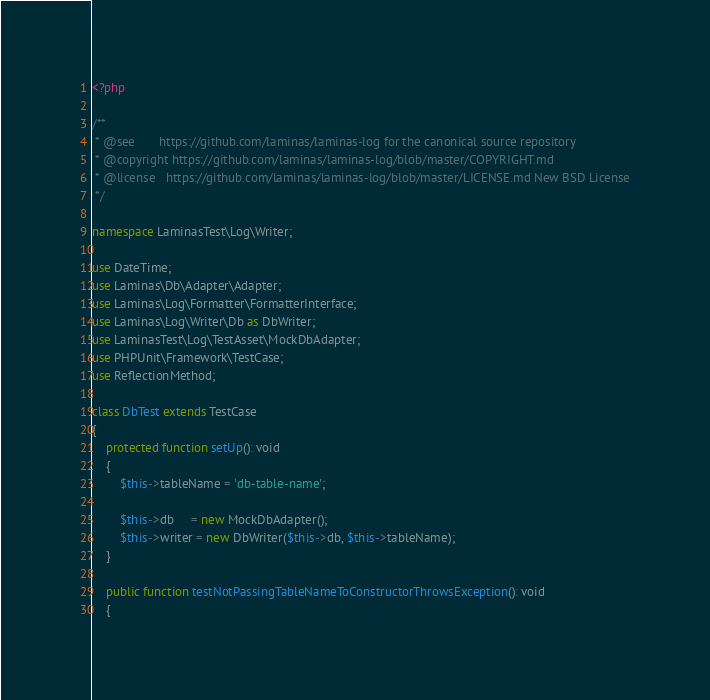<code> <loc_0><loc_0><loc_500><loc_500><_PHP_><?php

/**
 * @see       https://github.com/laminas/laminas-log for the canonical source repository
 * @copyright https://github.com/laminas/laminas-log/blob/master/COPYRIGHT.md
 * @license   https://github.com/laminas/laminas-log/blob/master/LICENSE.md New BSD License
 */

namespace LaminasTest\Log\Writer;

use DateTime;
use Laminas\Db\Adapter\Adapter;
use Laminas\Log\Formatter\FormatterInterface;
use Laminas\Log\Writer\Db as DbWriter;
use LaminasTest\Log\TestAsset\MockDbAdapter;
use PHPUnit\Framework\TestCase;
use ReflectionMethod;

class DbTest extends TestCase
{
    protected function setUp(): void
    {
        $this->tableName = 'db-table-name';

        $this->db     = new MockDbAdapter();
        $this->writer = new DbWriter($this->db, $this->tableName);
    }

    public function testNotPassingTableNameToConstructorThrowsException(): void
    {</code> 